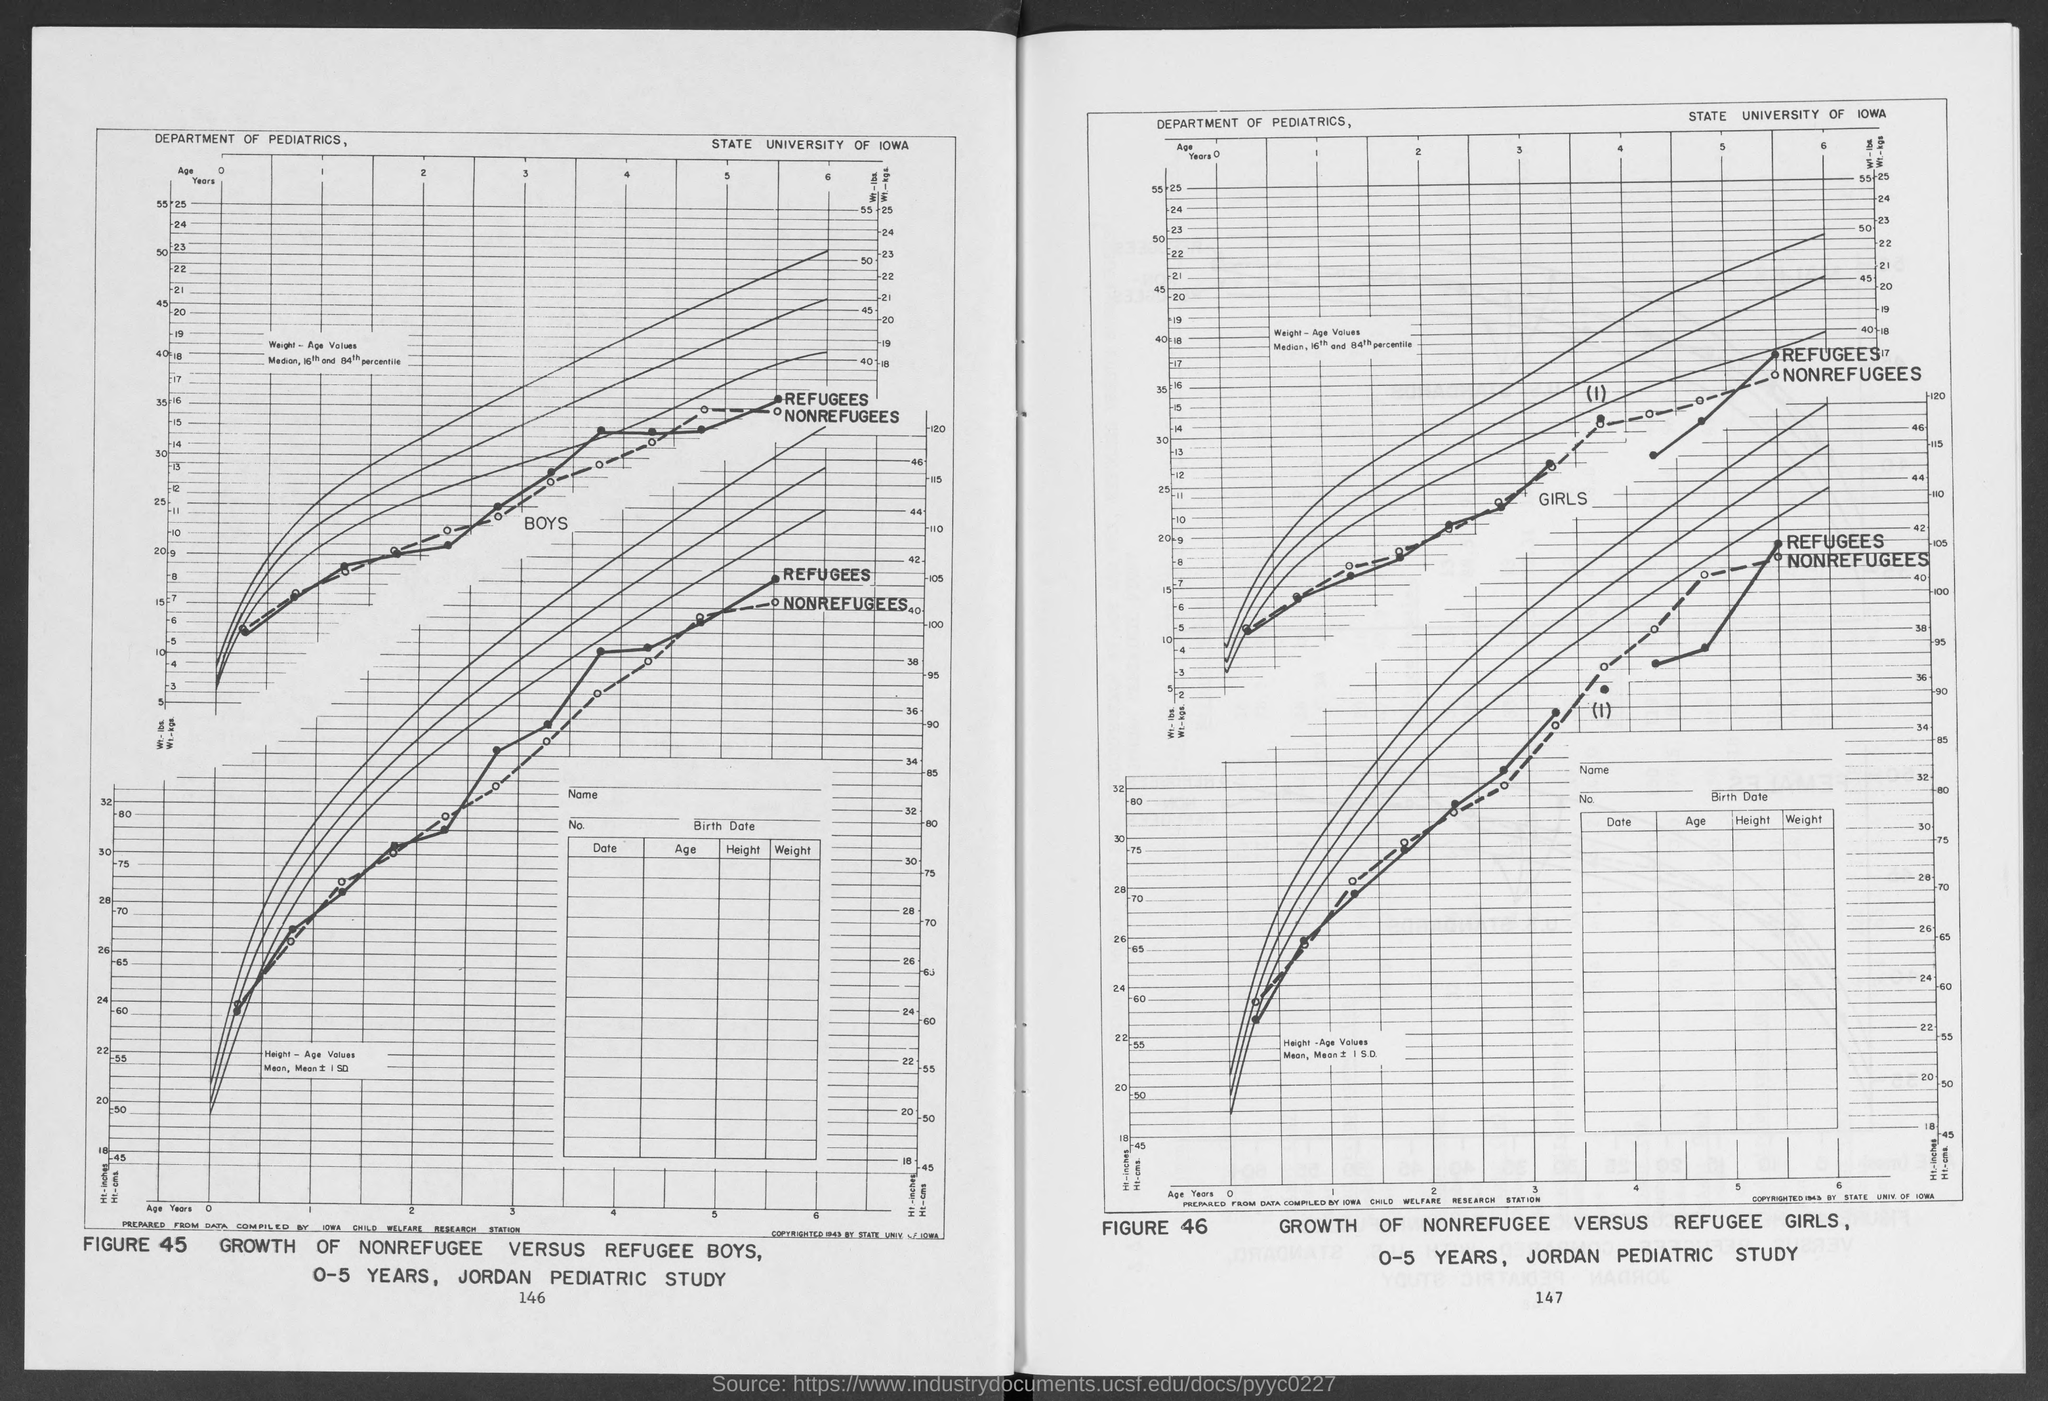Identify some key points in this picture. The graph was created by the Department of Pediatrics. Figure 45 titled 'Growth of nonrefugee versus refugee boys' displays a notable difference in the rates of growth between nonrefugee and refugee children. The University of Iowa is known as the State University of Iowa. The age range of the boys in the study is 0-5 years. 